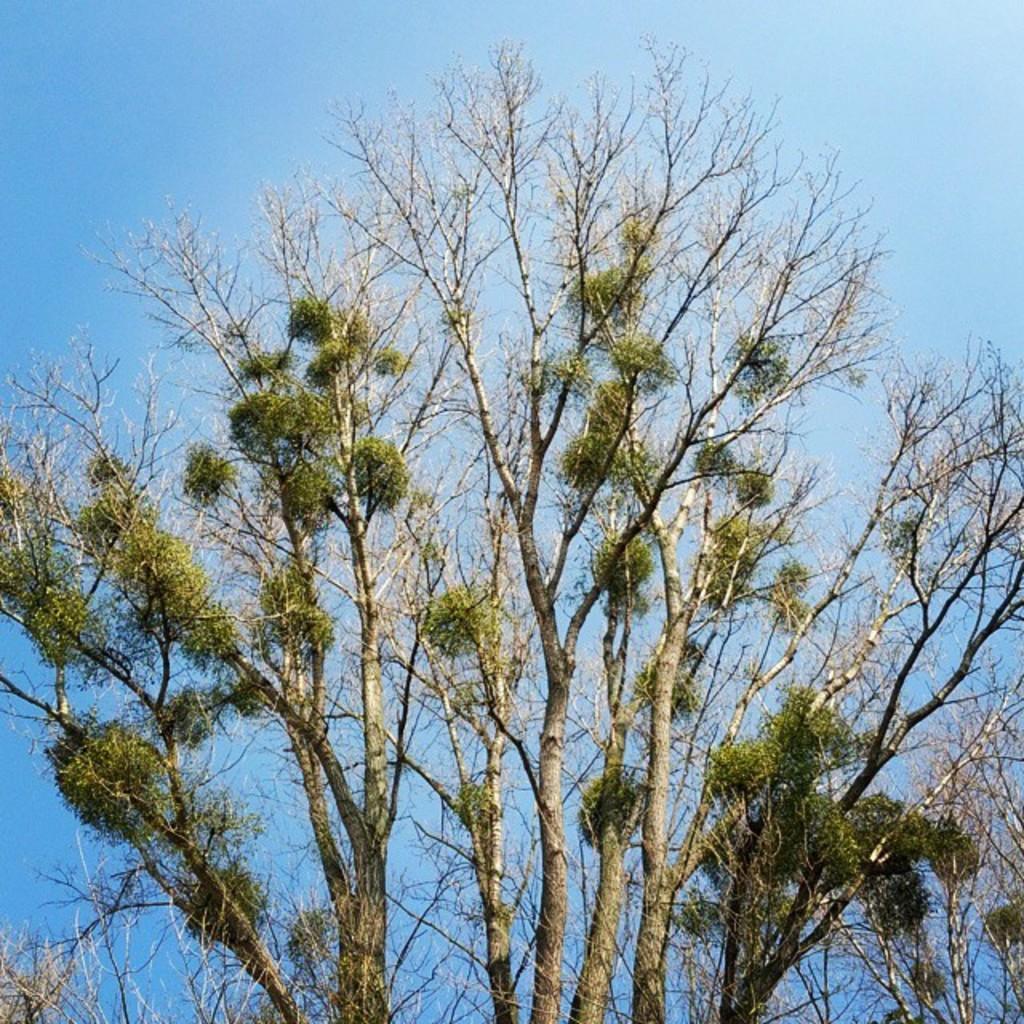Describe this image in one or two sentences. In the image there is a tree in the front and above its sky. 